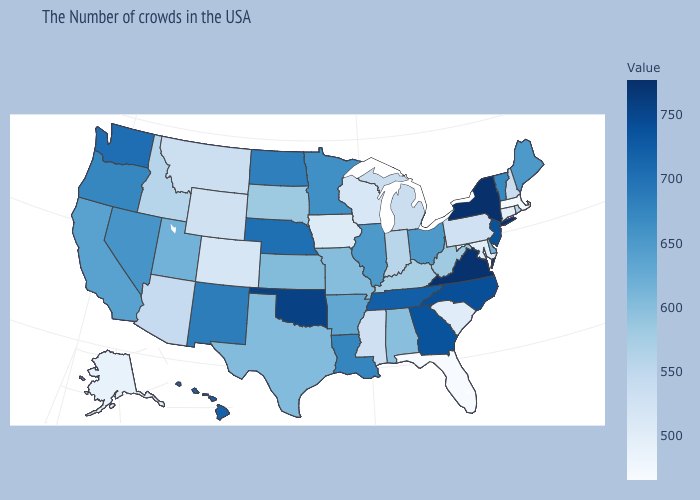Does Hawaii have a higher value than Alabama?
Keep it brief. Yes. Among the states that border Vermont , which have the lowest value?
Short answer required. Massachusetts. Which states have the highest value in the USA?
Answer briefly. New York. Is the legend a continuous bar?
Quick response, please. Yes. Does the map have missing data?
Short answer required. No. Which states have the lowest value in the MidWest?
Short answer required. Iowa. 